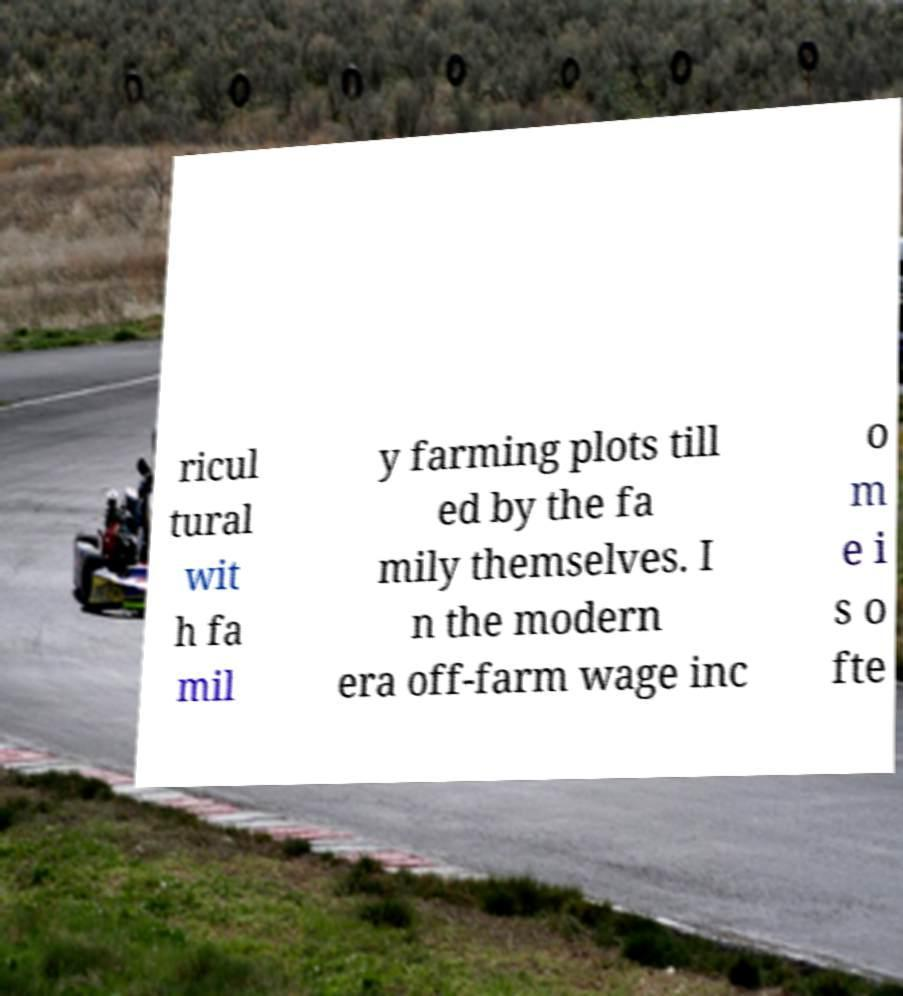Please read and relay the text visible in this image. What does it say? ricul tural wit h fa mil y farming plots till ed by the fa mily themselves. I n the modern era off-farm wage inc o m e i s o fte 